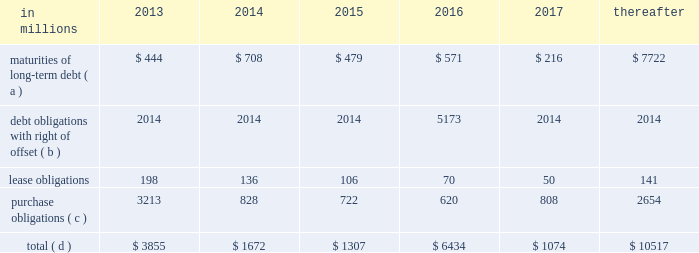Through current cash balances and cash from oper- ations .
Additionally , the company has existing credit facilities totaling $ 2.5 billion .
The company was in compliance with all its debt covenants at december 31 , 2012 .
The company 2019s financial covenants require the maintenance of a minimum net worth of $ 9 billion and a total debt-to- capital ratio of less than 60% ( 60 % ) .
Net worth is defined as the sum of common stock , paid-in capital and retained earnings , less treasury stock plus any cumulative goodwill impairment charges .
The calcu- lation also excludes accumulated other compre- hensive income/loss and nonrecourse financial liabilities of special purpose entities .
The total debt- to-capital ratio is defined as total debt divided by the sum of total debt plus net worth .
At december 31 , 2012 , international paper 2019s net worth was $ 13.9 bil- lion , and the total-debt-to-capital ratio was 42% ( 42 % ) .
The company will continue to rely upon debt and capital markets for the majority of any necessary long-term funding not provided by operating cash flows .
Funding decisions will be guided by our capi- tal structure planning objectives .
The primary goals of the company 2019s capital structure planning are to maximize financial flexibility and preserve liquidity while reducing interest expense .
The majority of international paper 2019s debt is accessed through global public capital markets where we have a wide base of investors .
Maintaining an investment grade credit rating is an important element of international paper 2019s financing strategy .
At december 31 , 2012 , the company held long-term credit ratings of bbb ( stable outlook ) and baa3 ( stable outlook ) by s&p and moody 2019s , respectively .
Contractual obligations for future payments under existing debt and lease commitments and purchase obligations at december 31 , 2012 , were as follows: .
( a ) total debt includes scheduled principal payments only .
( b ) represents debt obligations borrowed from non-consolidated variable interest entities for which international paper has , and intends to effect , a legal right to offset these obligations with investments held in the entities .
Accordingly , in its con- solidated balance sheet at december 31 , 2012 , international paper has offset approximately $ 5.2 billion of interests in the entities against this $ 5.2 billion of debt obligations held by the entities ( see note 11 variable interest entities and preferred securities of subsidiaries on pages 69 through 72 in item 8 .
Financial statements and supplementary data ) .
( c ) includes $ 3.6 billion relating to fiber supply agreements entered into at the time of the 2006 transformation plan forest- land sales and in conjunction with the 2008 acquisition of weyerhaeuser company 2019s containerboard , packaging and recycling business .
( d ) not included in the above table due to the uncertainty as to the amount and timing of the payment are unrecognized tax bene- fits of approximately $ 620 million .
We consider the undistributed earnings of our for- eign subsidiaries as of december 31 , 2012 , to be indefinitely reinvested and , accordingly , no u.s .
Income taxes have been provided thereon .
As of december 31 , 2012 , the amount of cash associated with indefinitely reinvested foreign earnings was approximately $ 840 million .
We do not anticipate the need to repatriate funds to the united states to sat- isfy domestic liquidity needs arising in the ordinary course of business , including liquidity needs asso- ciated with our domestic debt service requirements .
Pension obligations and funding at december 31 , 2012 , the projected benefit obliga- tion for the company 2019s u.s .
Defined benefit plans determined under u.s .
Gaap was approximately $ 4.1 billion higher than the fair value of plan assets .
Approximately $ 3.7 billion of this amount relates to plans that are subject to minimum funding require- ments .
Under current irs funding rules , the calcu- lation of minimum funding requirements differs from the calculation of the present value of plan benefits ( the projected benefit obligation ) for accounting purposes .
In december 2008 , the worker , retiree and employer recovery act of 2008 ( wera ) was passed by the u.s .
Congress which provided for pension funding relief and technical corrections .
Funding contributions depend on the funding method selected by the company , and the timing of its implementation , as well as on actual demo- graphic data and the targeted funding level .
The company continually reassesses the amount and timing of any discretionary contributions and elected to make voluntary contributions totaling $ 44 million and $ 300 million for the years ended december 31 , 2012 and 2011 , respectively .
At this time , we expect that required contributions to its plans in 2013 will be approximately $ 31 million , although the company may elect to make future voluntary contributions .
The timing and amount of future contributions , which could be material , will depend on a number of factors , including the actual earnings and changes in values of plan assets and changes in interest rates .
Ilim holding s.a .
Shareholder 2019s agreement in october 2007 , in connection with the for- mation of the ilim holding s.a .
Joint venture , international paper entered into a share- holder 2019s agreement that includes provisions relating to the reconciliation of disputes among the partners .
This agreement provides that at .
What percentage of contractual obligations for future payments under existing debt and lease commitments and purchase obligations at december 31 , 2012 is short term for the year 2014? 
Computations: ((136 + 828) / 1672)
Answer: 0.57656. 